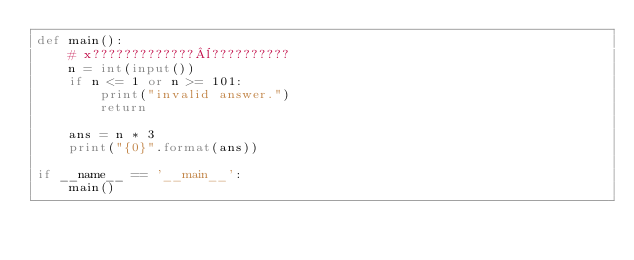<code> <loc_0><loc_0><loc_500><loc_500><_Python_>def main():
    # x?????????????¨??????????
    n = int(input())
    if n <= 1 or n >= 101:
        print("invalid answer.")
        return

    ans = n * 3
    print("{0}".format(ans))

if __name__ == '__main__':
    main()</code> 